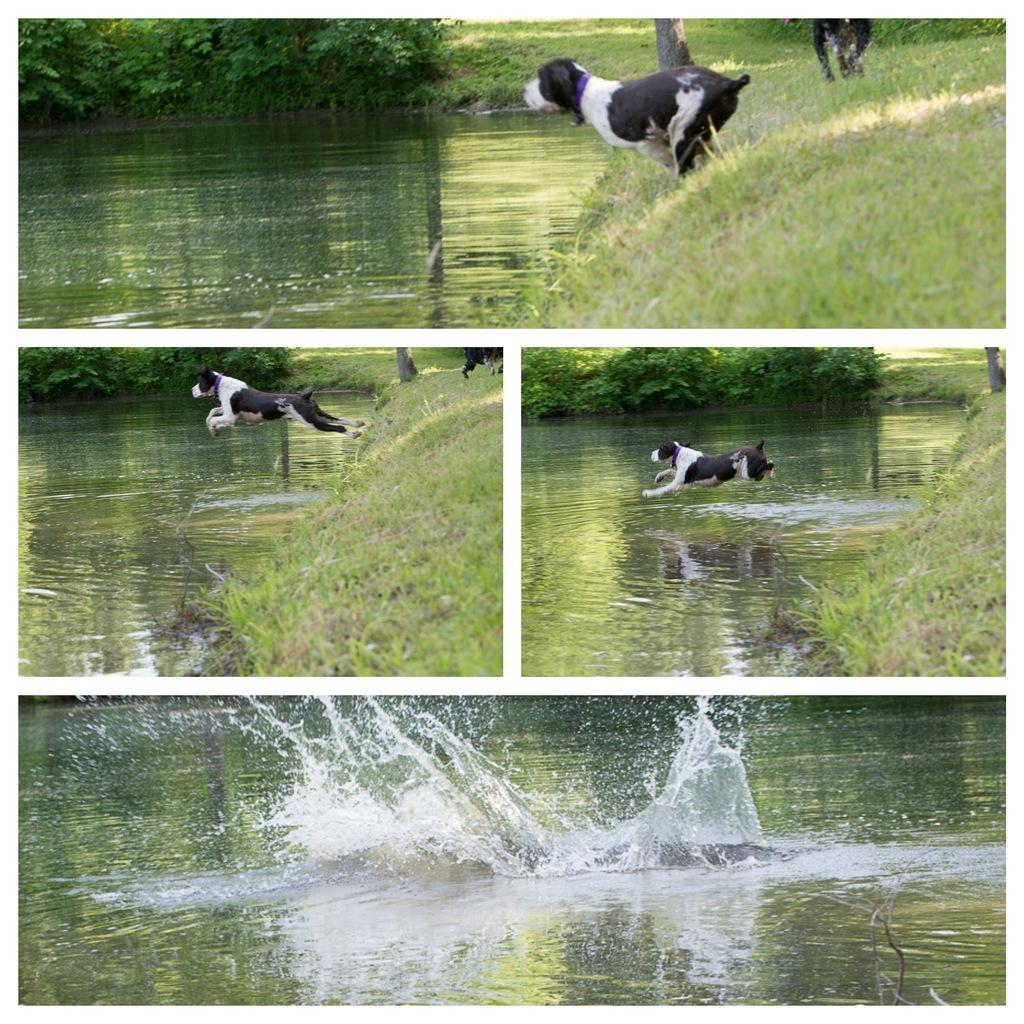What type of natural feature is present in the image? There is a river in the image. What type of vegetation can be seen in the image? There is grass and trees in the image. Are there any animals present in the image? Yes, there are dogs in the image. Can you see a kite flying in the image? There is no kite present in the image. Do the dogs have visible fangs in the image? The image does not show the dogs' teeth, so it cannot be determined if they have visible fangs. 